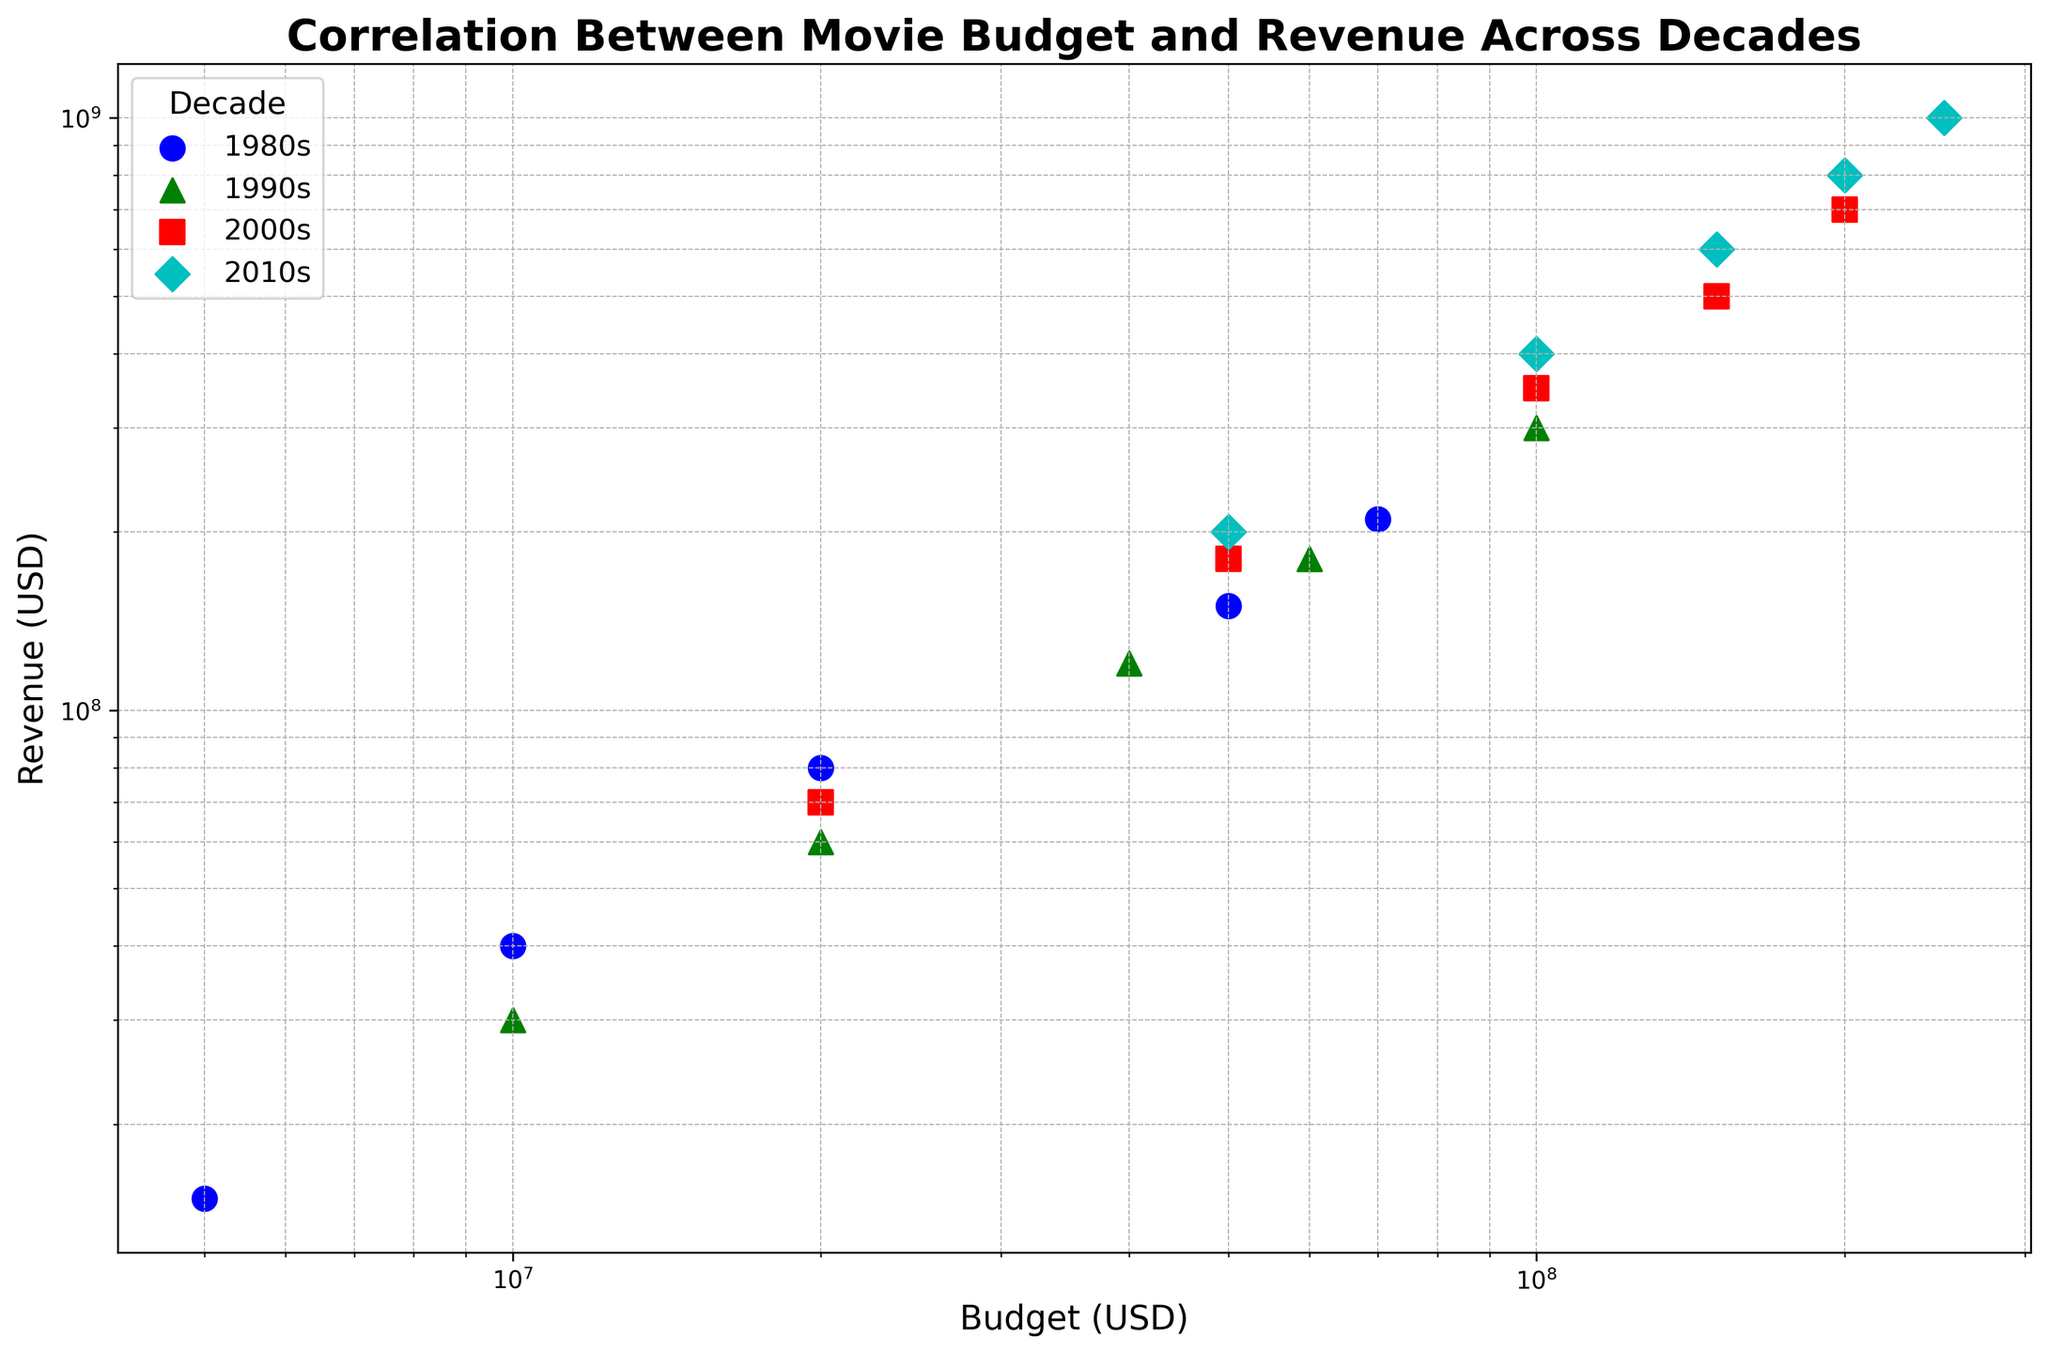Did any decade have outliers? To answer this, look for points that don't fit the general trend of their respective decade or are distant from other points in that decade. The 2000s and 2010s have a few high-budget movies with exceptionally high revenues, which can be considered outliers.
Answer: Yes Which decade had the highest maximum budget observed in the plot? Observe the scatter plot and look for the decade label with the point farthest to the right on the x-axis. This corresponds to the highest budget.
Answer: 2010s Which decade had the lowest minimum budget observed in the plot? Observe the scatter plot and look for the decade label with the point closest to the left on the x-axis. This point corresponds to the lowest budget.
Answer: 1980s Compare the 2000s and 2010s in terms of their average budget and revenue. Calculate the average budget and revenue for each decade. The 2000s have average values somewhere around mid-to-high budgets and revenues, while the 2010s show higher averages for both budget and revenue as observed from their respective cluster positioning on the higher end of the scatter plot.
Answer: 2010s have higher averages How does the spread of data points differ between the 1980s and the 2010s? Compare the range and distribution of data points for these decades. The 1980s show a tighter spread with less variation in both budget and revenue, whereas the 2010s show a larger spread indicating more variation.
Answer: 2010s have a larger spread Which decade shows the clearest positive correlation between budget and revenue? Determine the decade that has the data points forming the most linear line, indicating a strong positive correlation. Generally, all decades show a positive trend, but if one decade has its points more tightly aligned, it has the clearest positive correlation.
Answer: 2010s 